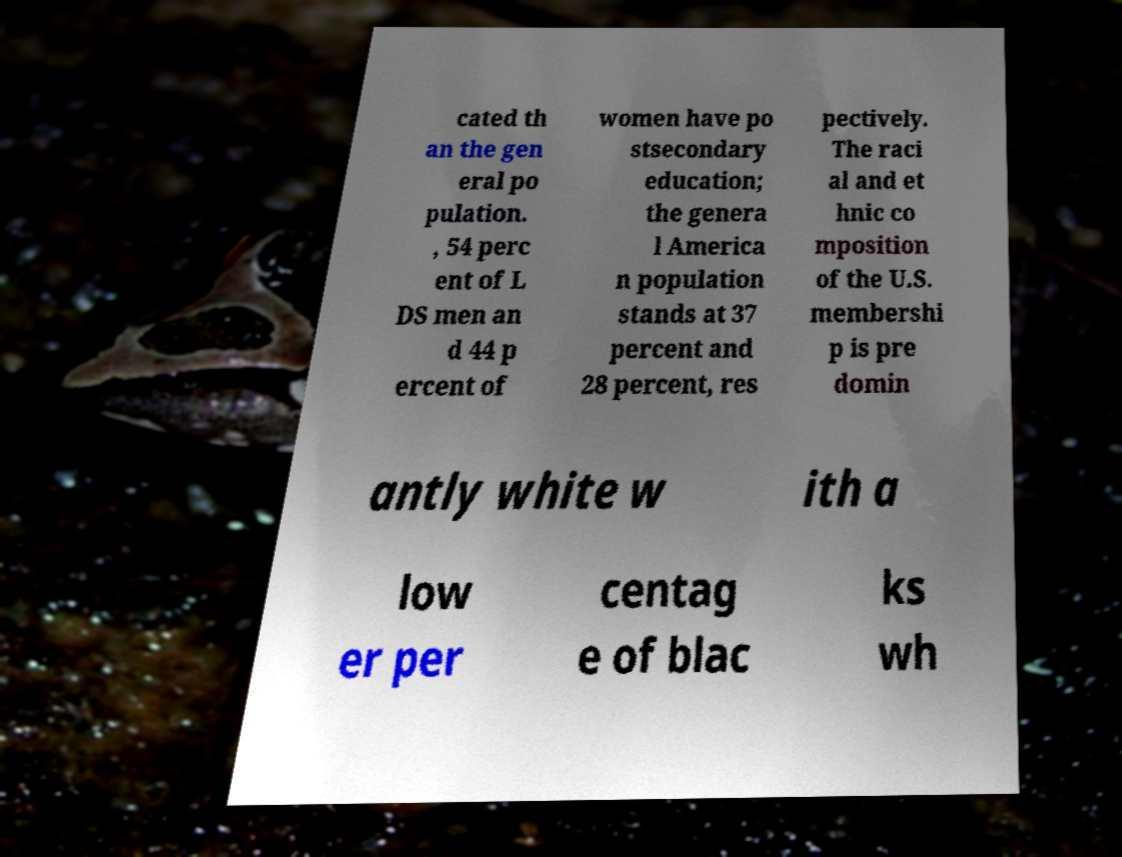Please read and relay the text visible in this image. What does it say? cated th an the gen eral po pulation. , 54 perc ent of L DS men an d 44 p ercent of women have po stsecondary education; the genera l America n population stands at 37 percent and 28 percent, res pectively. The raci al and et hnic co mposition of the U.S. membershi p is pre domin antly white w ith a low er per centag e of blac ks wh 